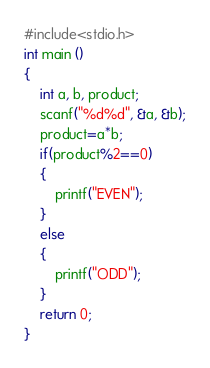<code> <loc_0><loc_0><loc_500><loc_500><_C_>#include<stdio.h>
int main ()
{
	int a, b, product;
	scanf("%d%d", &a, &b);
	product=a*b;
	if(product%2==0)
	{
		printf("EVEN");
	}
	else
	{
		printf("ODD");
	}
	return 0;
}</code> 